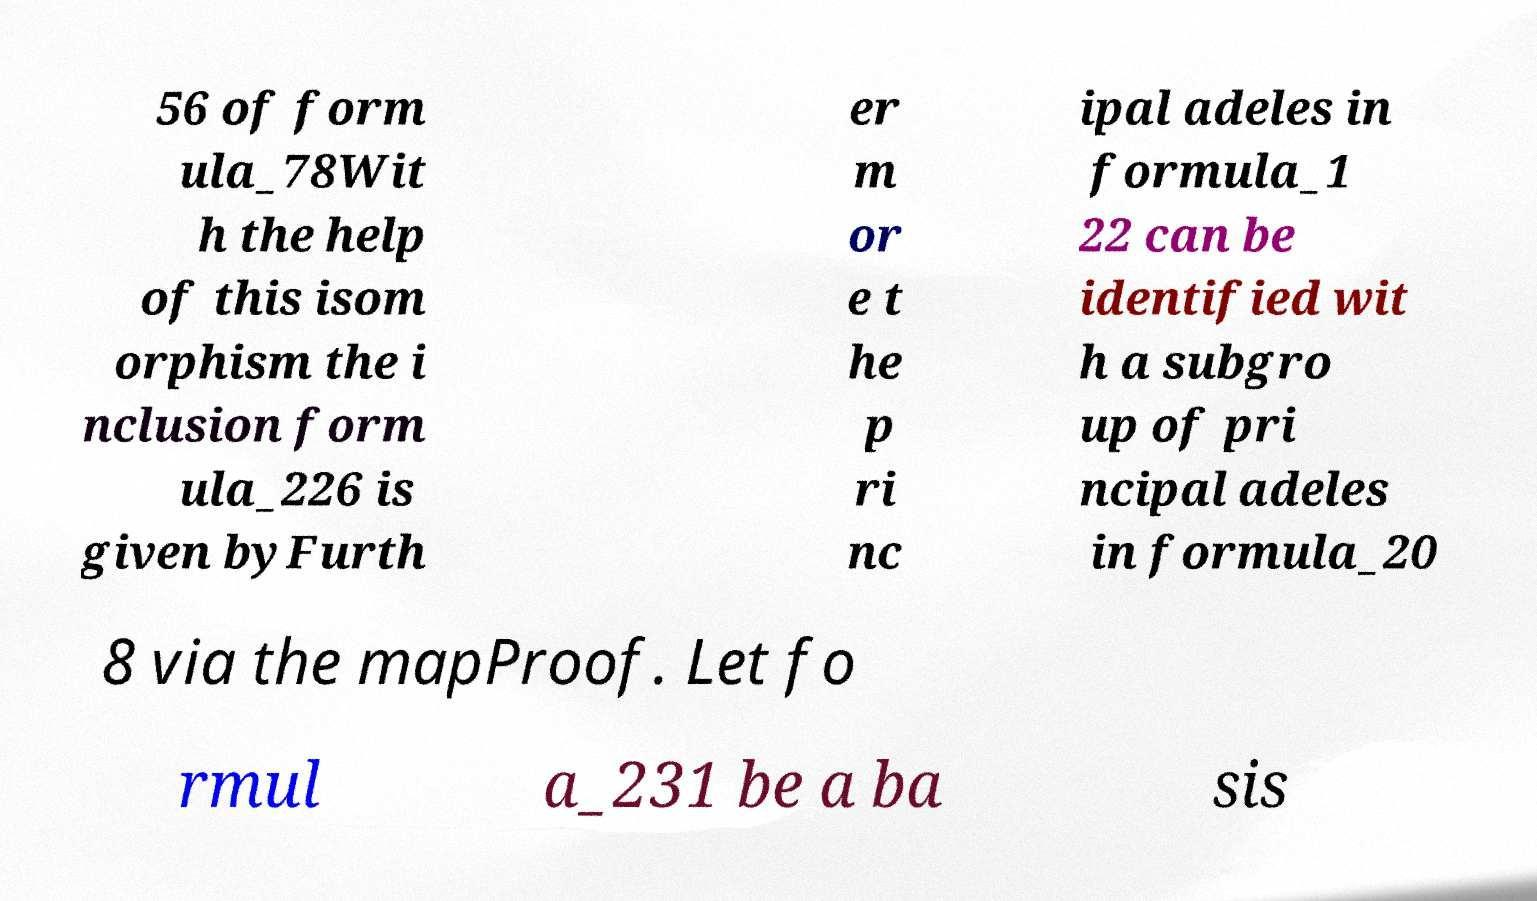Could you extract and type out the text from this image? 56 of form ula_78Wit h the help of this isom orphism the i nclusion form ula_226 is given byFurth er m or e t he p ri nc ipal adeles in formula_1 22 can be identified wit h a subgro up of pri ncipal adeles in formula_20 8 via the mapProof. Let fo rmul a_231 be a ba sis 